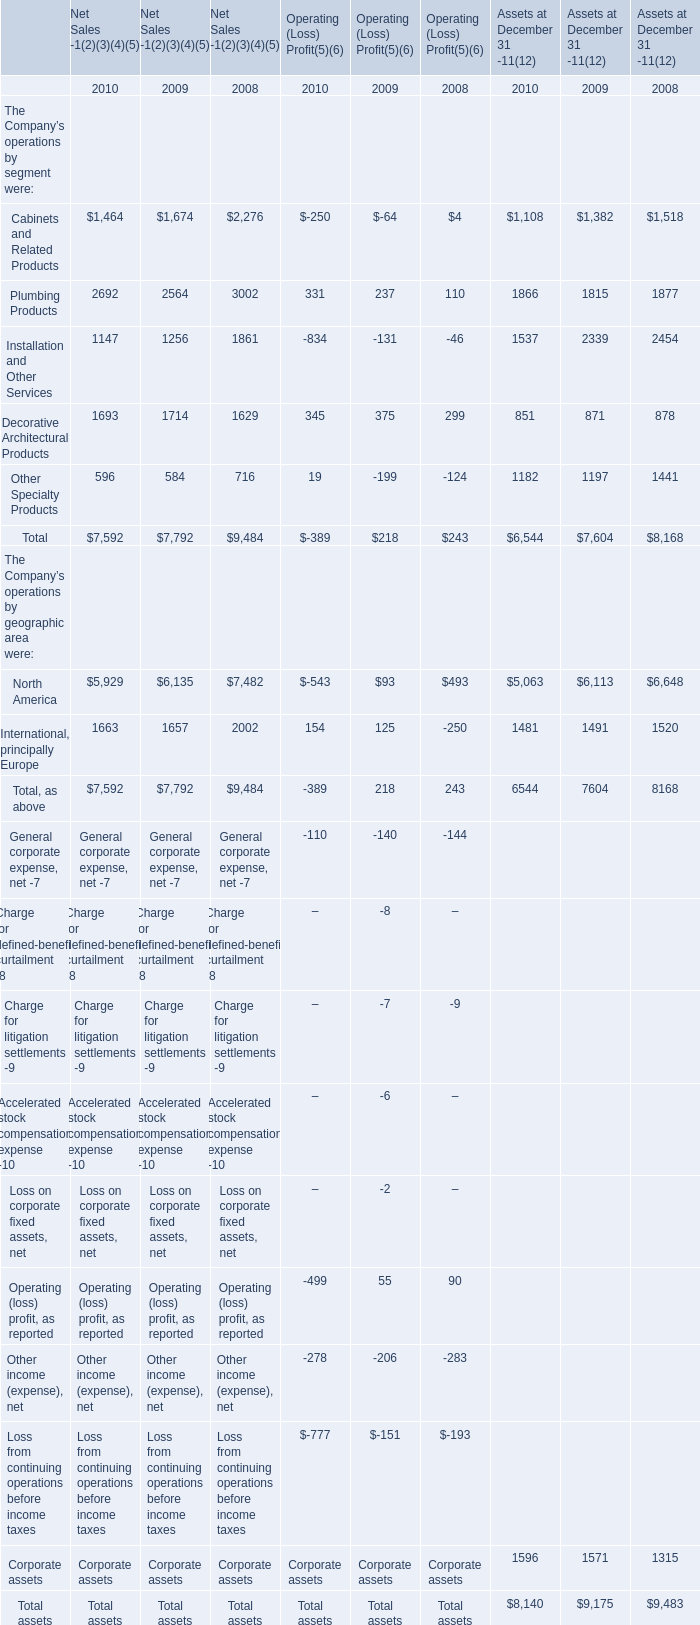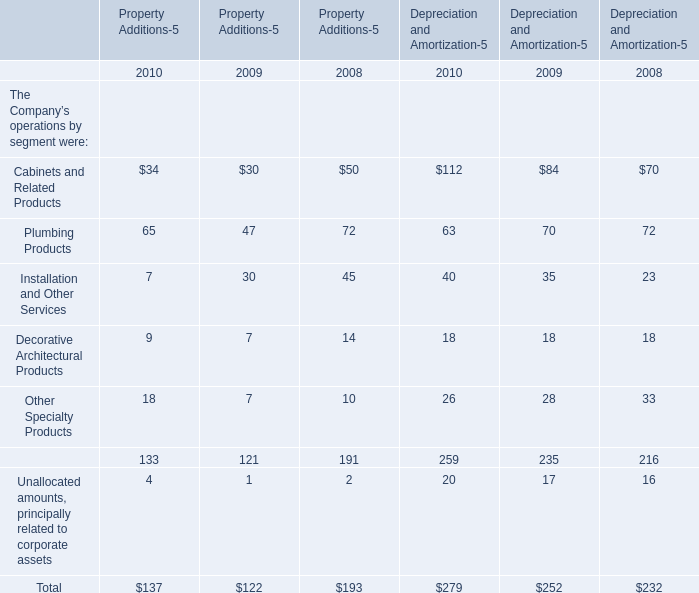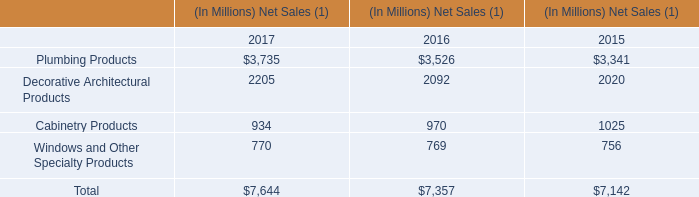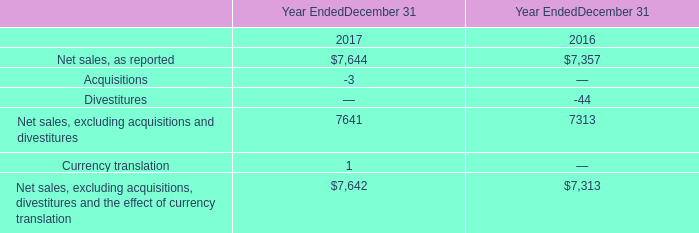In the year with least amount of Depreciation and Amortization in terms of Other Specialty Products, what's the growing rate of Depreciation and Amortization in terms of Plumbing Products? 
Computations: ((63 - 70) / 70)
Answer: -0.1. 